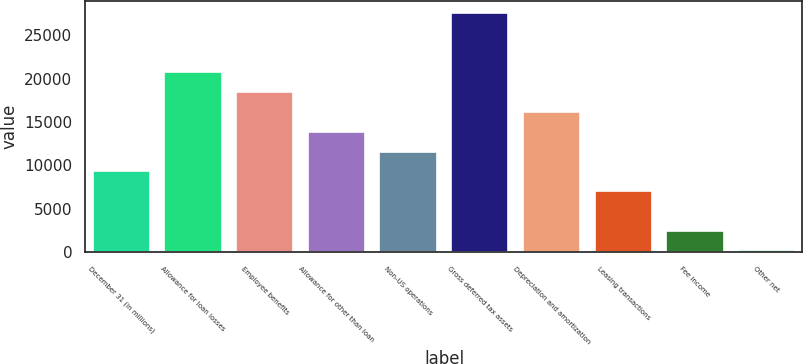Convert chart to OTSL. <chart><loc_0><loc_0><loc_500><loc_500><bar_chart><fcel>December 31 (in millions)<fcel>Allowance for loan losses<fcel>Employee benefits<fcel>Allowance for other than loan<fcel>Non-US operations<fcel>Gross deferred tax assets<fcel>Depreciation and amortization<fcel>Leasing transactions<fcel>Fee income<fcel>Other net<nl><fcel>9324.4<fcel>20727.4<fcel>18446.8<fcel>13885.6<fcel>11605<fcel>27569.2<fcel>16166.2<fcel>7043.8<fcel>2482.6<fcel>202<nl></chart> 